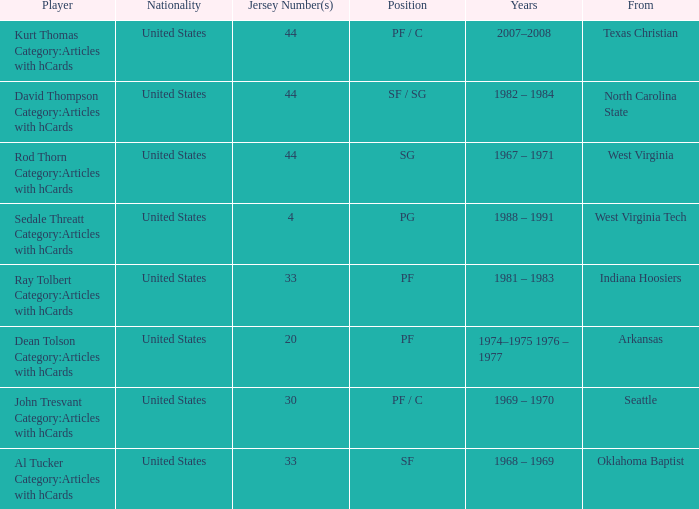What years did the player with the jersey number 33 and played position pf play? 1981 – 1983. Would you mind parsing the complete table? {'header': ['Player', 'Nationality', 'Jersey Number(s)', 'Position', 'Years', 'From'], 'rows': [['Kurt Thomas Category:Articles with hCards', 'United States', '44', 'PF / C', '2007–2008', 'Texas Christian'], ['David Thompson Category:Articles with hCards', 'United States', '44', 'SF / SG', '1982 – 1984', 'North Carolina State'], ['Rod Thorn Category:Articles with hCards', 'United States', '44', 'SG', '1967 – 1971', 'West Virginia'], ['Sedale Threatt Category:Articles with hCards', 'United States', '4', 'PG', '1988 – 1991', 'West Virginia Tech'], ['Ray Tolbert Category:Articles with hCards', 'United States', '33', 'PF', '1981 – 1983', 'Indiana Hoosiers'], ['Dean Tolson Category:Articles with hCards', 'United States', '20', 'PF', '1974–1975 1976 – 1977', 'Arkansas'], ['John Tresvant Category:Articles with hCards', 'United States', '30', 'PF / C', '1969 – 1970', 'Seattle'], ['Al Tucker Category:Articles with hCards', 'United States', '33', 'SF', '1968 – 1969', 'Oklahoma Baptist']]} 